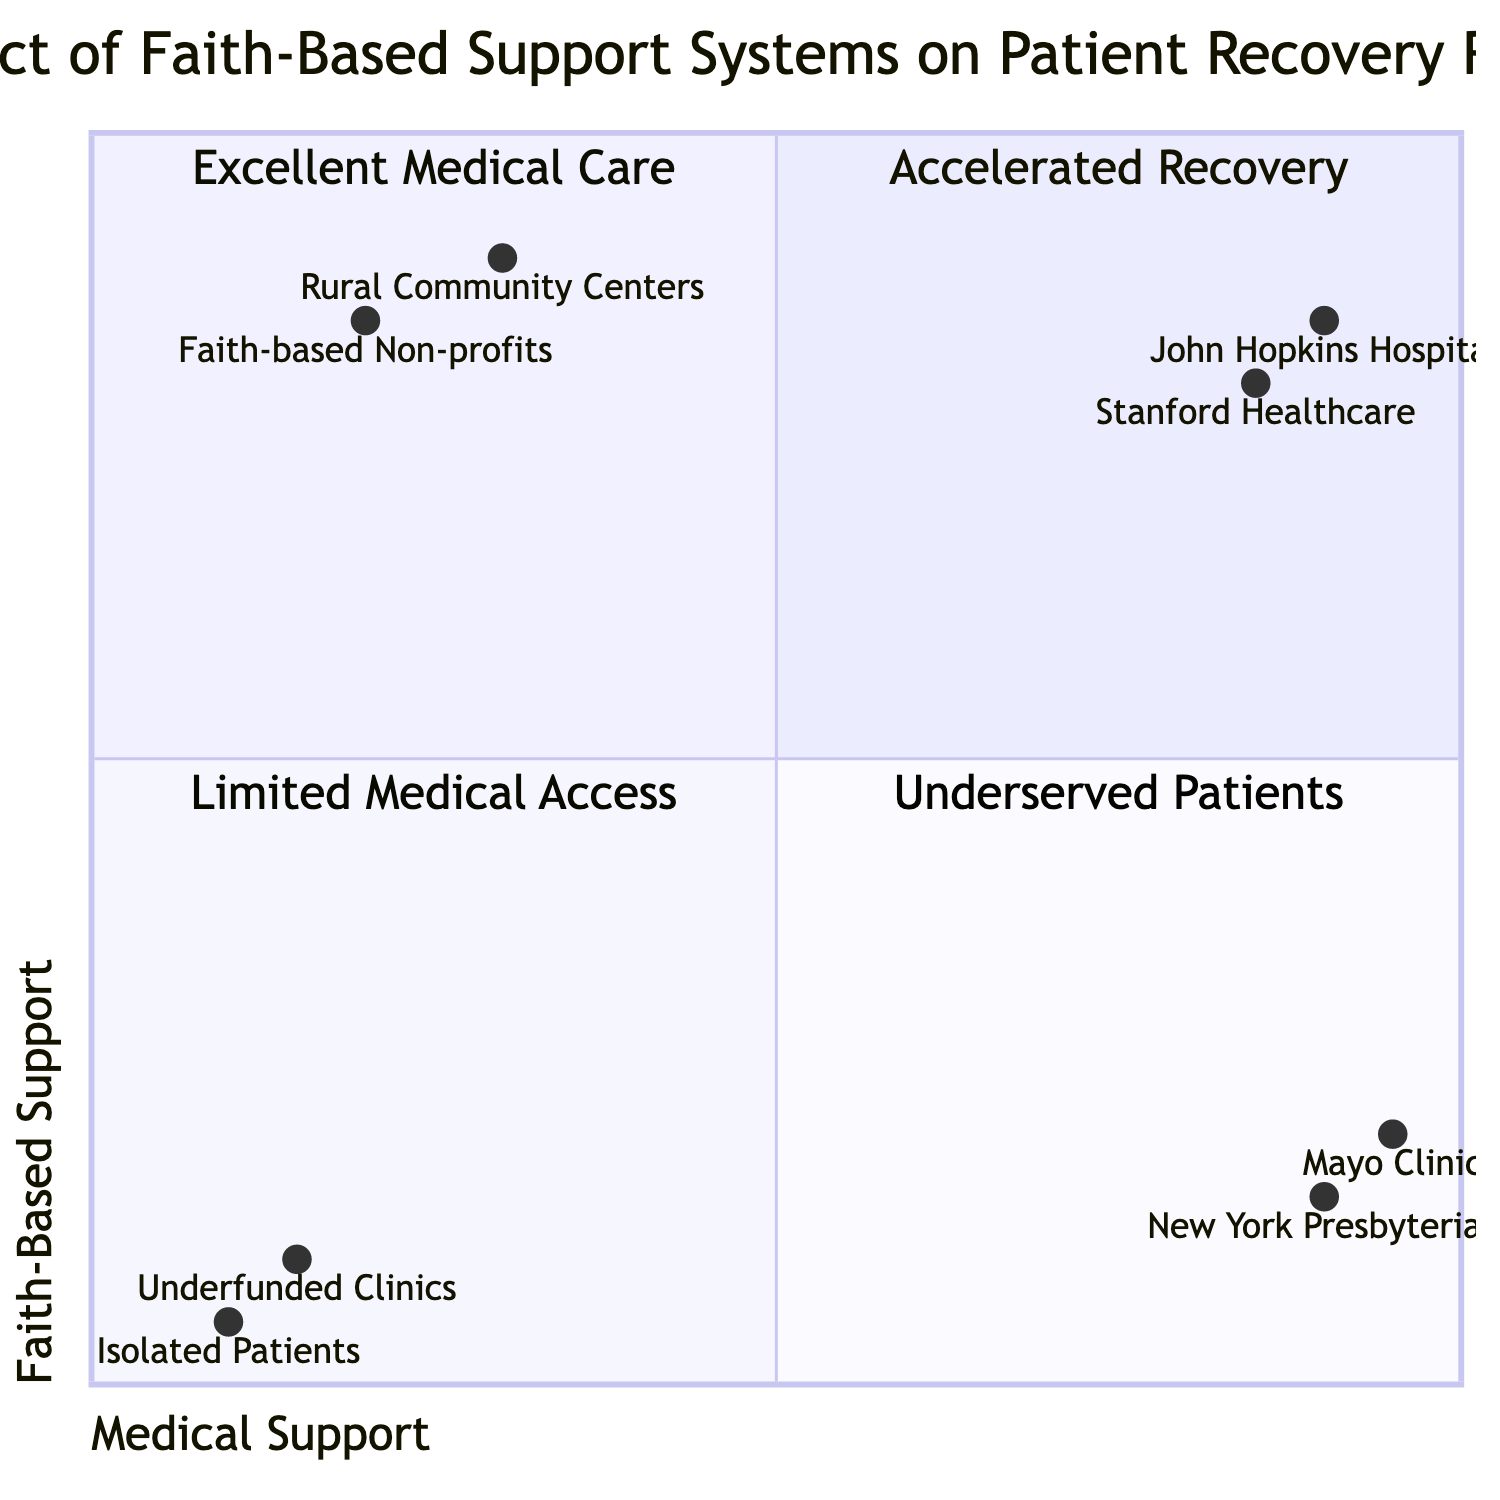What is the description of the first quadrant? The first quadrant, titled "High Medical Support & High Faith-Based Support," describes that patients experience accelerated recovery when they have combined medical treatments and support from religious communities.
Answer: Patients experience accelerated recovery with combined medical treatments and support systems from religious communities How many examples are listed for "Low Medical Support & High Faith-Based Support"? There are two examples listed in the quadrant titled "Low Medical Support & High Faith-Based Support," which detail situations where patients rely primarily on faith-based support without sufficient medical facilities.
Answer: 2 Which hospital is associated with the highest medical support score? From the data provided in the diagram, Mayo Clinic has the highest medical support score of 0.95, indicating it offers superior medical care compared to others listed.
Answer: Mayo Clinic What would be the expected recovery scenario for patients at underfunded clinics? In the quadrant labeled "Low Medical Support & Low Faith-Based Support," underfunded clinics are described as having limited access to both high-quality medical care and significant faith-based support, indicating a poor recovery scenario.
Answer: Limited access to both high-quality medical care and faith-based support Which organization is noted for having significant faith-based support yet limited medical interventions? The quadrant "Low Medical Support & High Faith-Based Support" mentions faith-based non-profits as providing emotional and spiritual support without extensive medical interventions, illustrating reliance on faith-based systems due to insufficient medical resources.
Answer: Faith-based non-profits What can be inferred about the recovery rates in the quadrant with low medical support and low faith-based support? Patients in the "Low Medical Support & Low Faith-Based Support" quadrant likely experience the poorest recovery rates because they lack both necessary medical care and faith-based assistance, which are crucial for recovery.
Answer: Poorest recovery rates How do the recovery scenarios differ between the first quadrant and the fourth quadrant? The first quadrant, "High Medical Support & High Faith-Based Support," indicates accelerated recovery due to both medical and spiritual support, while the fourth quadrant, "Low Medical Support & Low Faith-Based Support," signifies limited recovery options, highlighting a stark contrast in support availability.
Answer: Accelerated recovery vs. limited recovery options Which entity is likely to offer both advanced medical therapies and spiritual healing? According to the examples in the first quadrant, Stanford Healthcare is noted for providing advanced medical therapies along with spiritual healing sessions, showcasing the benefits of an integrated approach.
Answer: Stanford Healthcare 